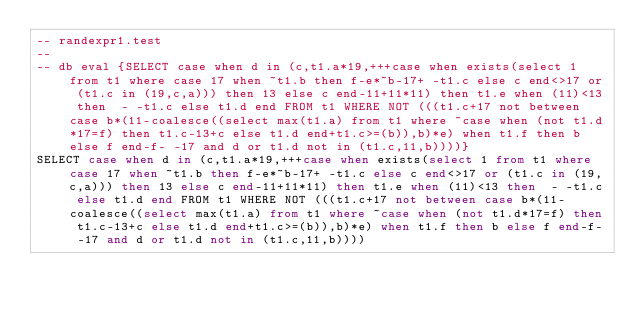<code> <loc_0><loc_0><loc_500><loc_500><_SQL_>-- randexpr1.test
-- 
-- db eval {SELECT case when d in (c,t1.a*19,+++case when exists(select 1 from t1 where case 17 when ~t1.b then f-e*~b-17+ -t1.c else c end<>17 or (t1.c in (19,c,a))) then 13 else c end-11+11*11) then t1.e when (11)<13 then  - -t1.c else t1.d end FROM t1 WHERE NOT (((t1.c+17 not between case b*(11-coalesce((select max(t1.a) from t1 where ~case when (not t1.d*17=f) then t1.c-13+c else t1.d end+t1.c>=(b)),b)*e) when t1.f then b else f end-f- -17 and d or t1.d not in (t1.c,11,b))))}
SELECT case when d in (c,t1.a*19,+++case when exists(select 1 from t1 where case 17 when ~t1.b then f-e*~b-17+ -t1.c else c end<>17 or (t1.c in (19,c,a))) then 13 else c end-11+11*11) then t1.e when (11)<13 then  - -t1.c else t1.d end FROM t1 WHERE NOT (((t1.c+17 not between case b*(11-coalesce((select max(t1.a) from t1 where ~case when (not t1.d*17=f) then t1.c-13+c else t1.d end+t1.c>=(b)),b)*e) when t1.f then b else f end-f- -17 and d or t1.d not in (t1.c,11,b))))</code> 